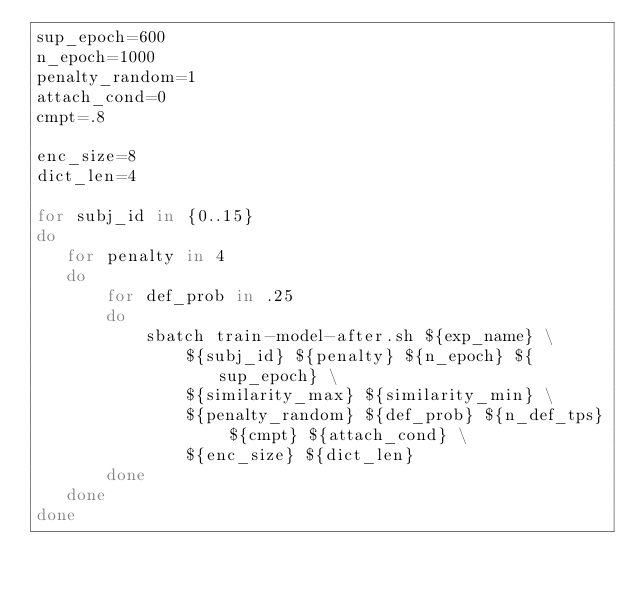Convert code to text. <code><loc_0><loc_0><loc_500><loc_500><_Bash_>sup_epoch=600
n_epoch=1000
penalty_random=1
attach_cond=0
cmpt=.8

enc_size=8
dict_len=4

for subj_id in {0..15}
do
   for penalty in 4
   do
       for def_prob in .25
       do
           sbatch train-model-after.sh ${exp_name} \
               ${subj_id} ${penalty} ${n_epoch} ${sup_epoch} \
               ${similarity_max} ${similarity_min} \
               ${penalty_random} ${def_prob} ${n_def_tps} ${cmpt} ${attach_cond} \
               ${enc_size} ${dict_len}
       done
   done
done
</code> 